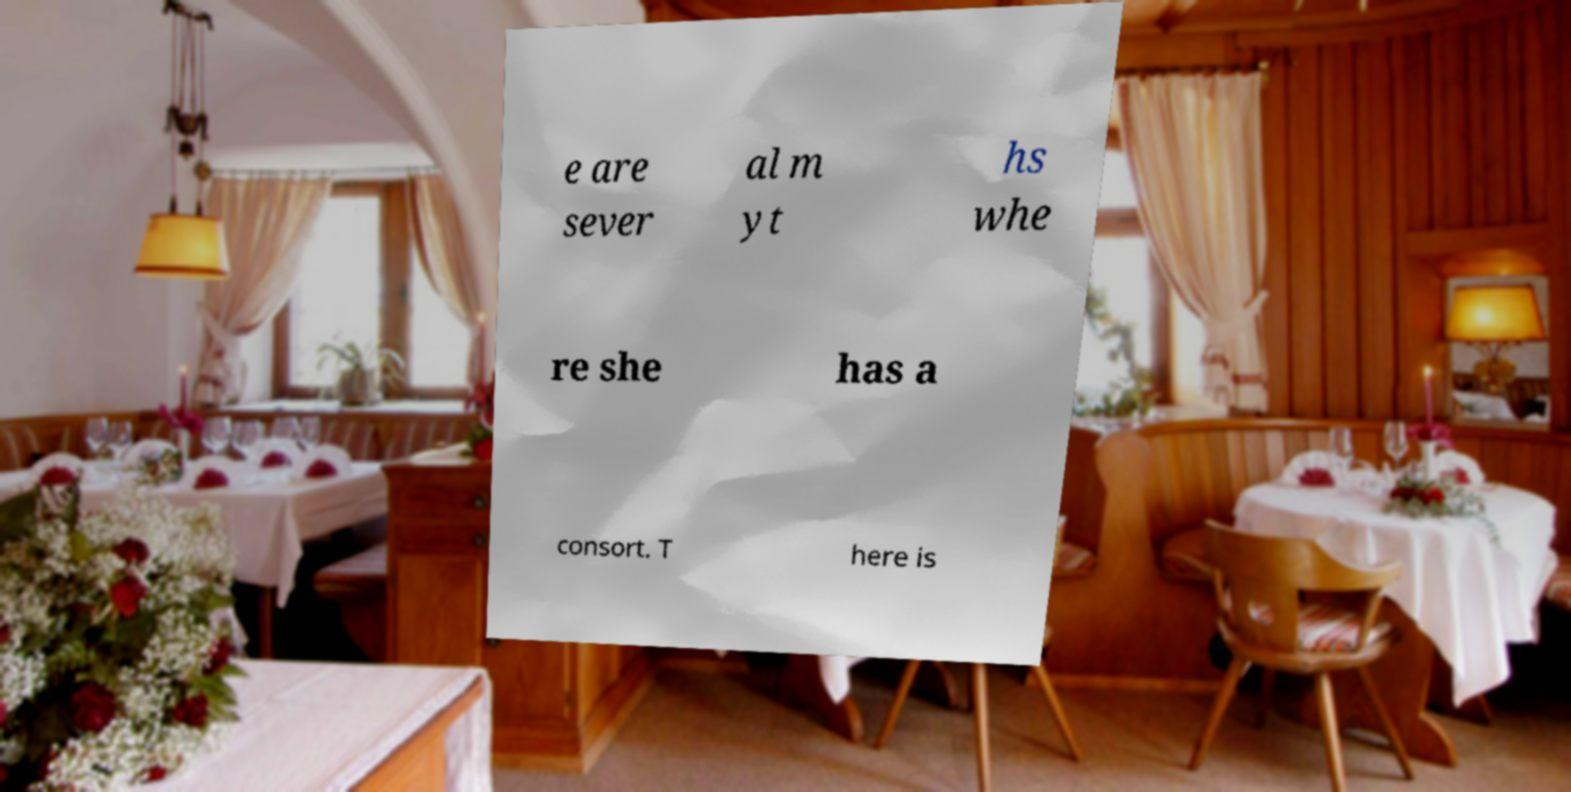Please identify and transcribe the text found in this image. e are sever al m yt hs whe re she has a consort. T here is 